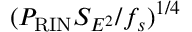Convert formula to latex. <formula><loc_0><loc_0><loc_500><loc_500>( P _ { R I N } S _ { E ^ { 2 } } / f _ { s } ) ^ { 1 / 4 }</formula> 